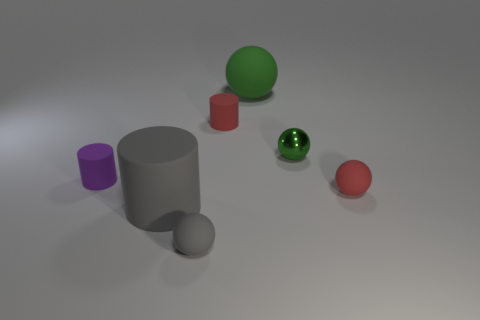Subtract all green balls. How many were subtracted if there are1green balls left? 1 Subtract 1 spheres. How many spheres are left? 3 Subtract all gray spheres. How many spheres are left? 3 Subtract all tiny green spheres. How many spheres are left? 3 Subtract all purple spheres. Subtract all yellow cylinders. How many spheres are left? 4 Add 3 green rubber things. How many objects exist? 10 Subtract all cylinders. How many objects are left? 4 Add 4 large rubber balls. How many large rubber balls are left? 5 Add 2 tiny spheres. How many tiny spheres exist? 5 Subtract 0 purple balls. How many objects are left? 7 